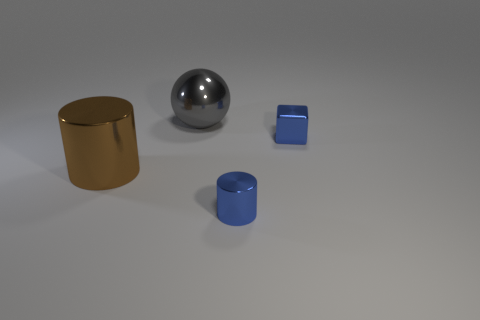Add 1 big green metal spheres. How many objects exist? 5 Subtract all spheres. How many objects are left? 3 Subtract all purple metal cylinders. Subtract all brown metal objects. How many objects are left? 3 Add 4 gray spheres. How many gray spheres are left? 5 Add 4 big metal cylinders. How many big metal cylinders exist? 5 Subtract 0 red spheres. How many objects are left? 4 